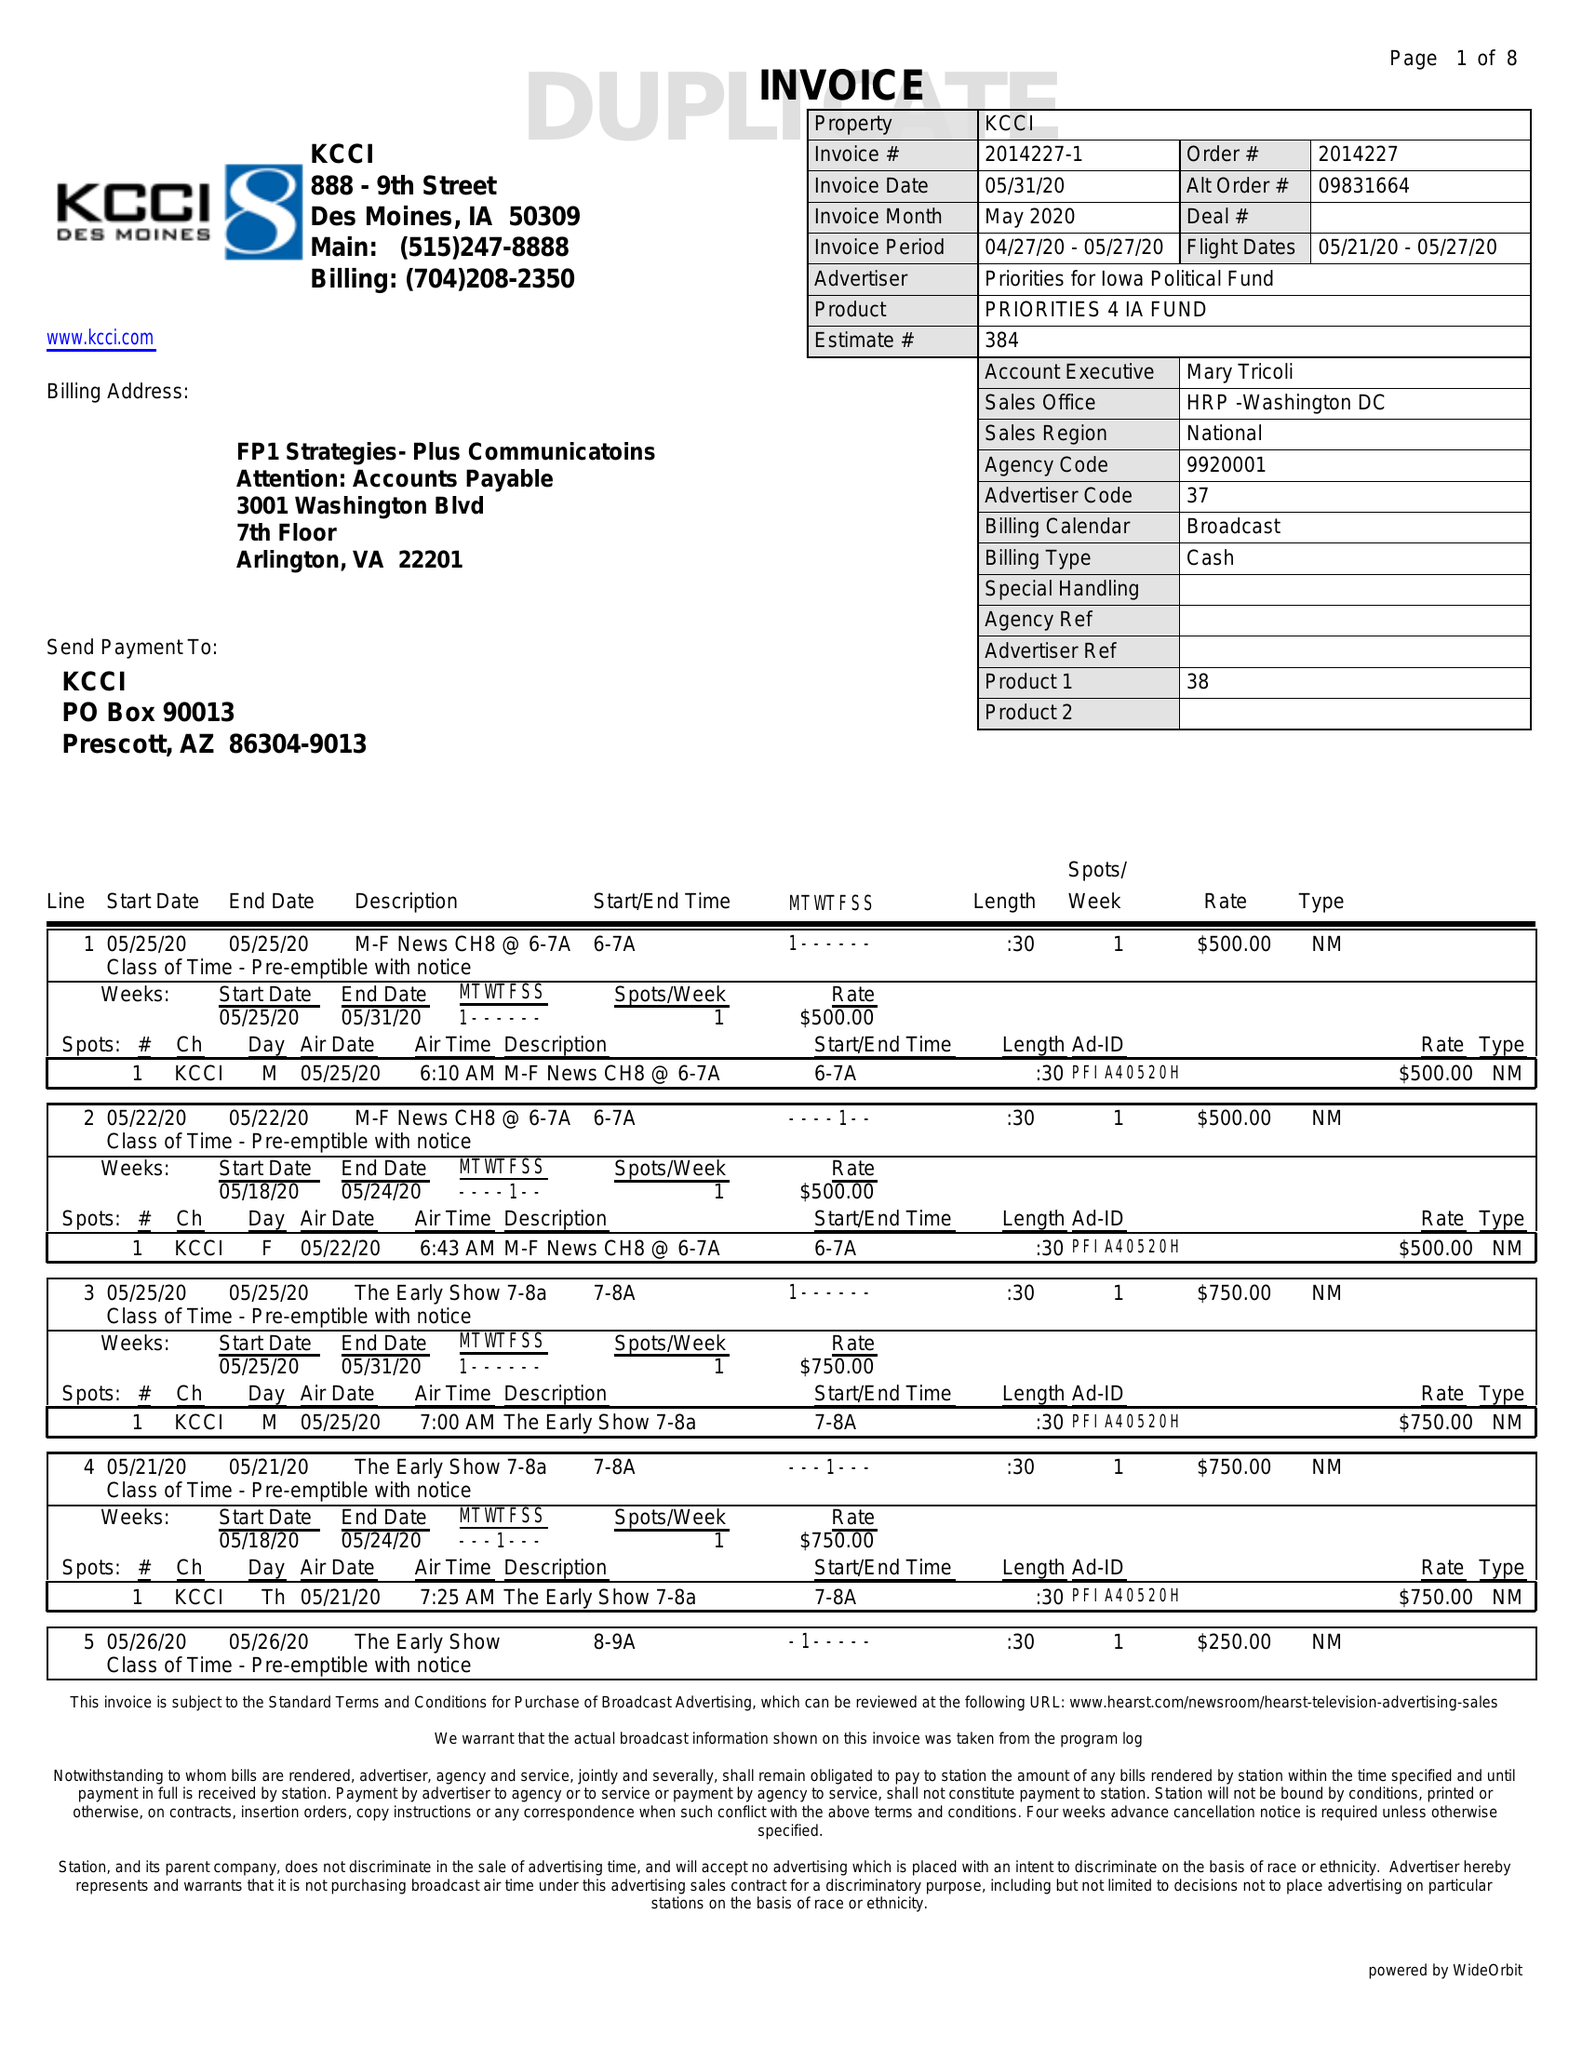What is the value for the advertiser?
Answer the question using a single word or phrase. PRIORITIES FOR IOWA POLITICAL FUND 